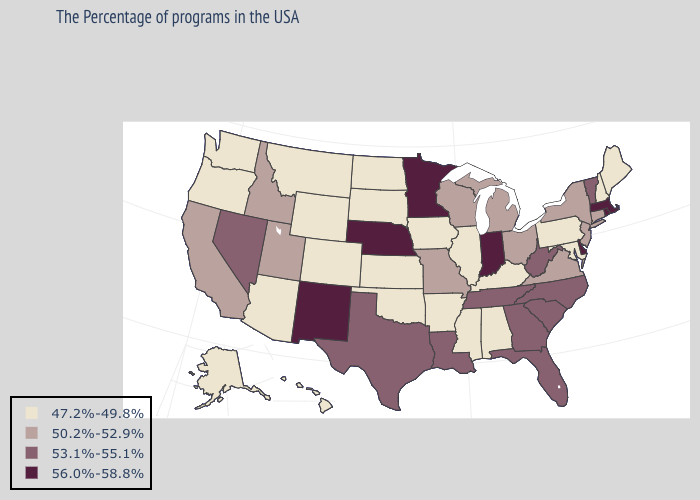Name the states that have a value in the range 53.1%-55.1%?
Be succinct. Vermont, North Carolina, South Carolina, West Virginia, Florida, Georgia, Tennessee, Louisiana, Texas, Nevada. Name the states that have a value in the range 50.2%-52.9%?
Keep it brief. Connecticut, New York, New Jersey, Virginia, Ohio, Michigan, Wisconsin, Missouri, Utah, Idaho, California. Which states have the lowest value in the USA?
Write a very short answer. Maine, New Hampshire, Maryland, Pennsylvania, Kentucky, Alabama, Illinois, Mississippi, Arkansas, Iowa, Kansas, Oklahoma, South Dakota, North Dakota, Wyoming, Colorado, Montana, Arizona, Washington, Oregon, Alaska, Hawaii. Which states have the highest value in the USA?
Short answer required. Massachusetts, Rhode Island, Delaware, Indiana, Minnesota, Nebraska, New Mexico. Does Arizona have a lower value than Washington?
Give a very brief answer. No. Name the states that have a value in the range 53.1%-55.1%?
Keep it brief. Vermont, North Carolina, South Carolina, West Virginia, Florida, Georgia, Tennessee, Louisiana, Texas, Nevada. Name the states that have a value in the range 56.0%-58.8%?
Keep it brief. Massachusetts, Rhode Island, Delaware, Indiana, Minnesota, Nebraska, New Mexico. What is the value of New Jersey?
Short answer required. 50.2%-52.9%. What is the value of Wisconsin?
Concise answer only. 50.2%-52.9%. What is the highest value in states that border Pennsylvania?
Concise answer only. 56.0%-58.8%. Does Arizona have the same value as Oregon?
Write a very short answer. Yes. Among the states that border Rhode Island , which have the lowest value?
Short answer required. Connecticut. Does Massachusetts have the highest value in the Northeast?
Give a very brief answer. Yes. Name the states that have a value in the range 56.0%-58.8%?
Concise answer only. Massachusetts, Rhode Island, Delaware, Indiana, Minnesota, Nebraska, New Mexico. Among the states that border Pennsylvania , does Delaware have the highest value?
Give a very brief answer. Yes. 